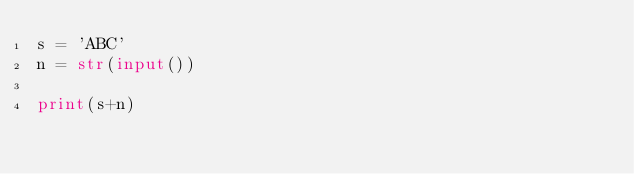<code> <loc_0><loc_0><loc_500><loc_500><_Python_>s = 'ABC'
n = str(input())

print(s+n)</code> 